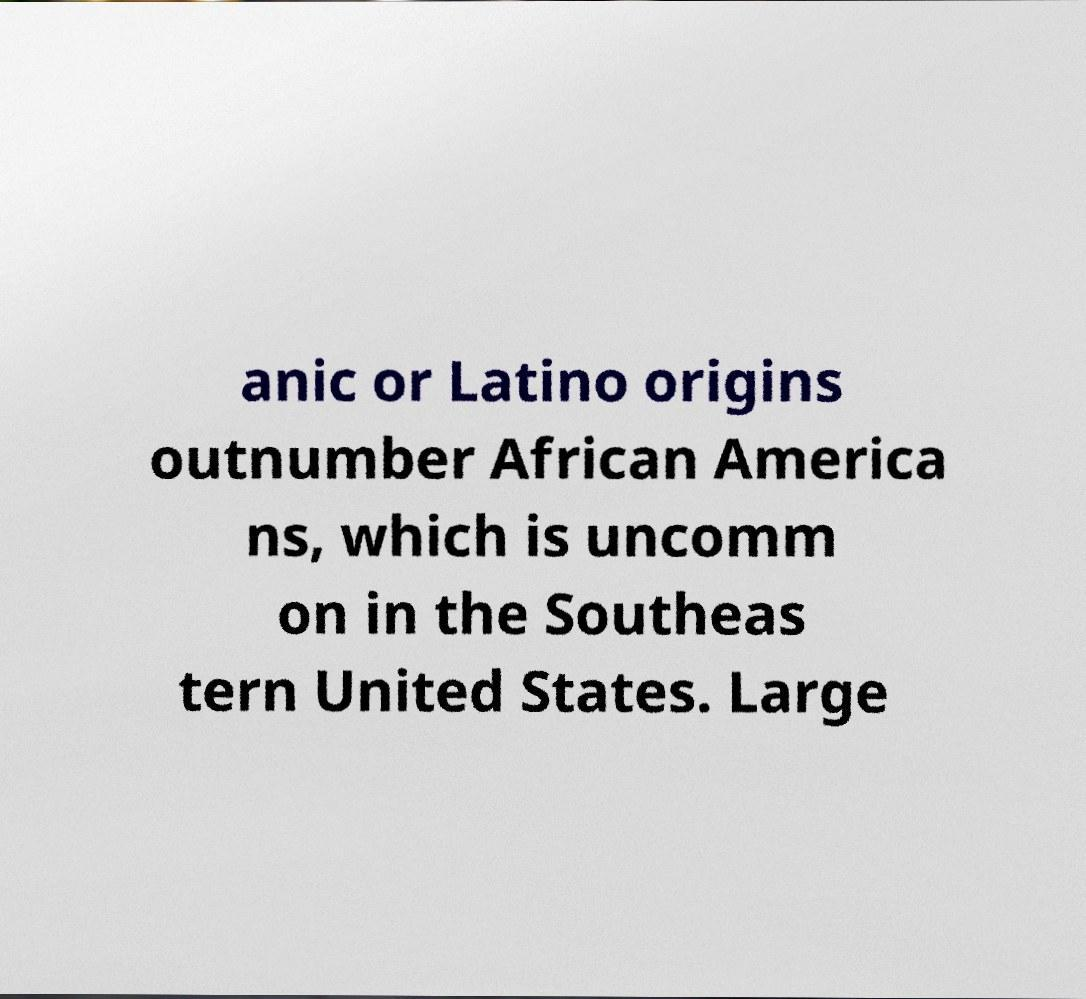Could you extract and type out the text from this image? anic or Latino origins outnumber African America ns, which is uncomm on in the Southeas tern United States. Large 